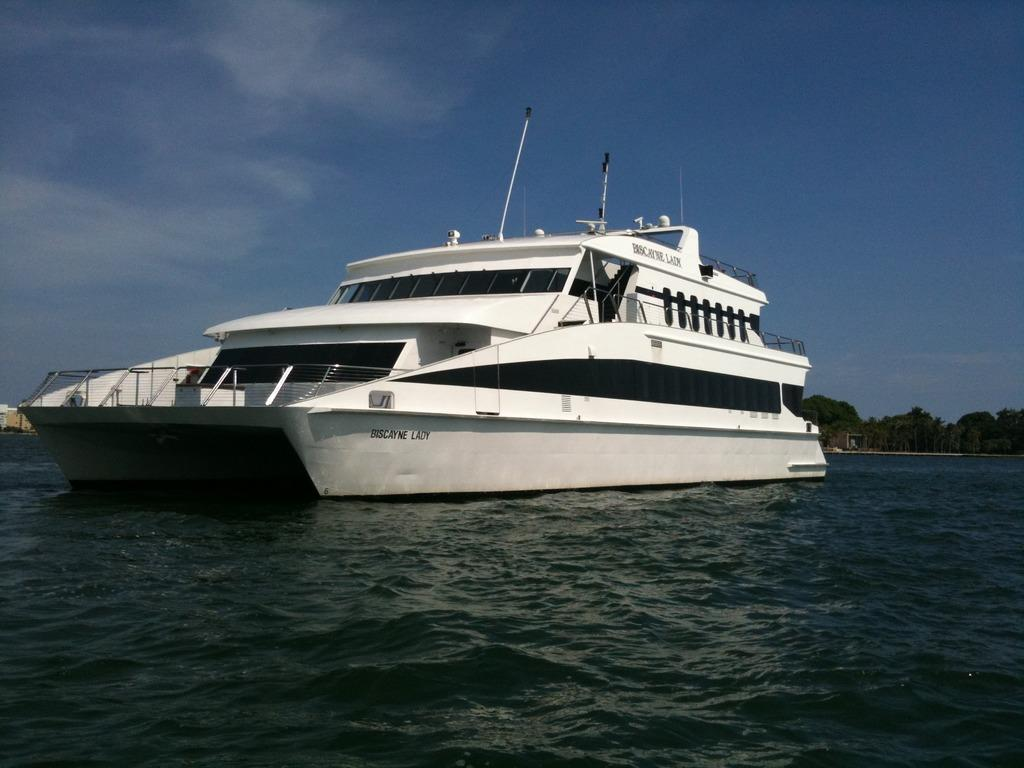What is the main subject in the center of the image? There is a boat in the center of the image. What type of vegetation can be seen in the image? Trees are present in the image. What is visible at the bottom of the image? There is water visible at the bottom of the image. What is visible in the sky at the top of the image? Clouds are present in the sky at the top of the image. Where is the secretary located in the image? There is no secretary present in the image. What type of plantation can be seen in the image? There is no plantation present in the image. 